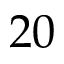<formula> <loc_0><loc_0><loc_500><loc_500>2 0</formula> 